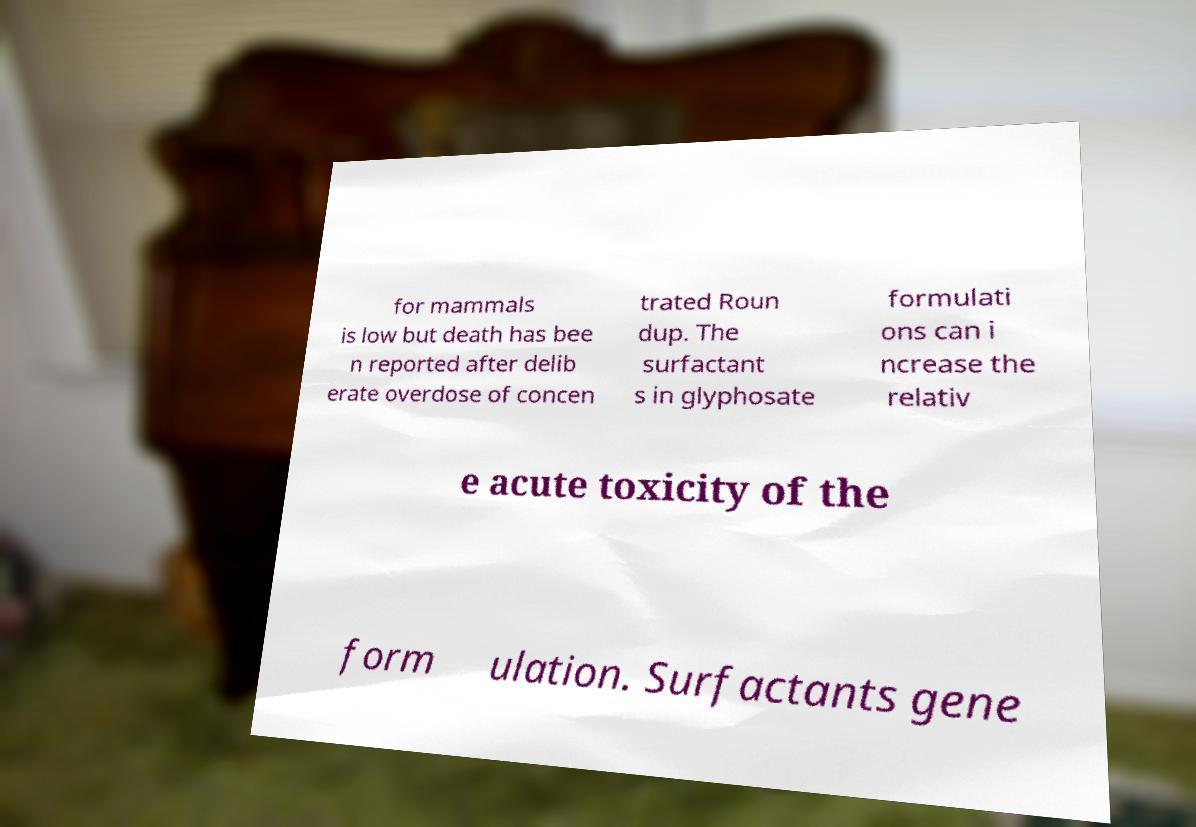Please read and relay the text visible in this image. What does it say? for mammals is low but death has bee n reported after delib erate overdose of concen trated Roun dup. The surfactant s in glyphosate formulati ons can i ncrease the relativ e acute toxicity of the form ulation. Surfactants gene 